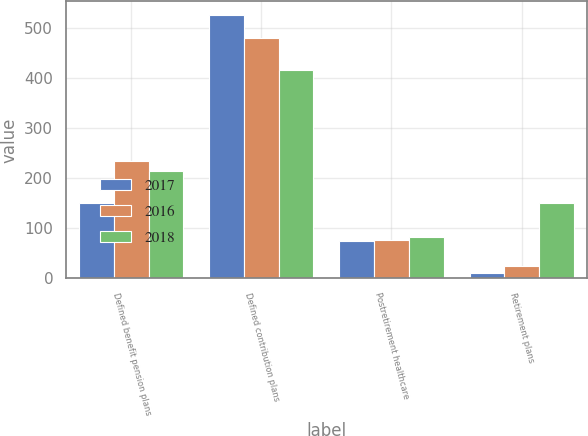<chart> <loc_0><loc_0><loc_500><loc_500><stacked_bar_chart><ecel><fcel>Defined benefit pension plans<fcel>Defined contribution plans<fcel>Postretirement healthcare<fcel>Retirement plans<nl><fcel>2017<fcel>150<fcel>527<fcel>74<fcel>10<nl><fcel>2016<fcel>234<fcel>480<fcel>76<fcel>24<nl><fcel>2018<fcel>214<fcel>416<fcel>82<fcel>150<nl></chart> 